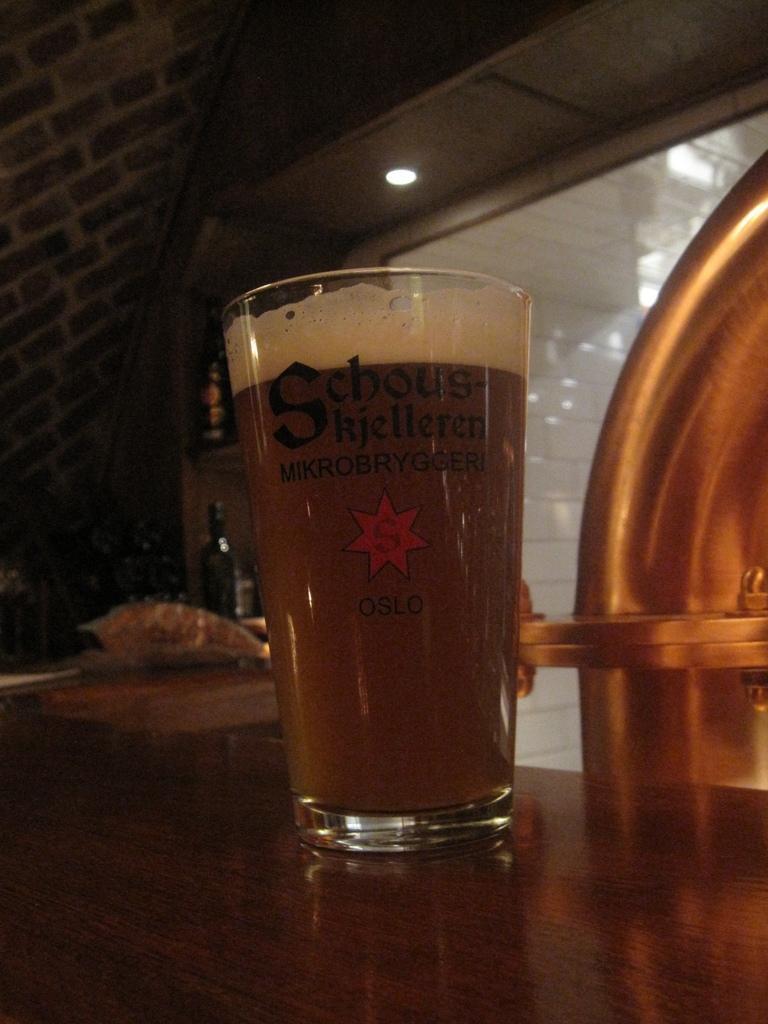How would you summarize this image in a sentence or two? In this image I can see a glass contain a drink visible on the table at the top I can see the roof ,wall and a light visible on the roof and I can see a bottle kept on the table in the middle 